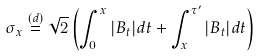Convert formula to latex. <formula><loc_0><loc_0><loc_500><loc_500>\sigma _ { x } \stackrel { ( d ) } { = } \sqrt { 2 } \left ( \int _ { 0 } ^ { x } | B _ { t } | d t + \int _ { x } ^ { \tau ^ { \prime } } | B _ { t } | d t \right )</formula> 